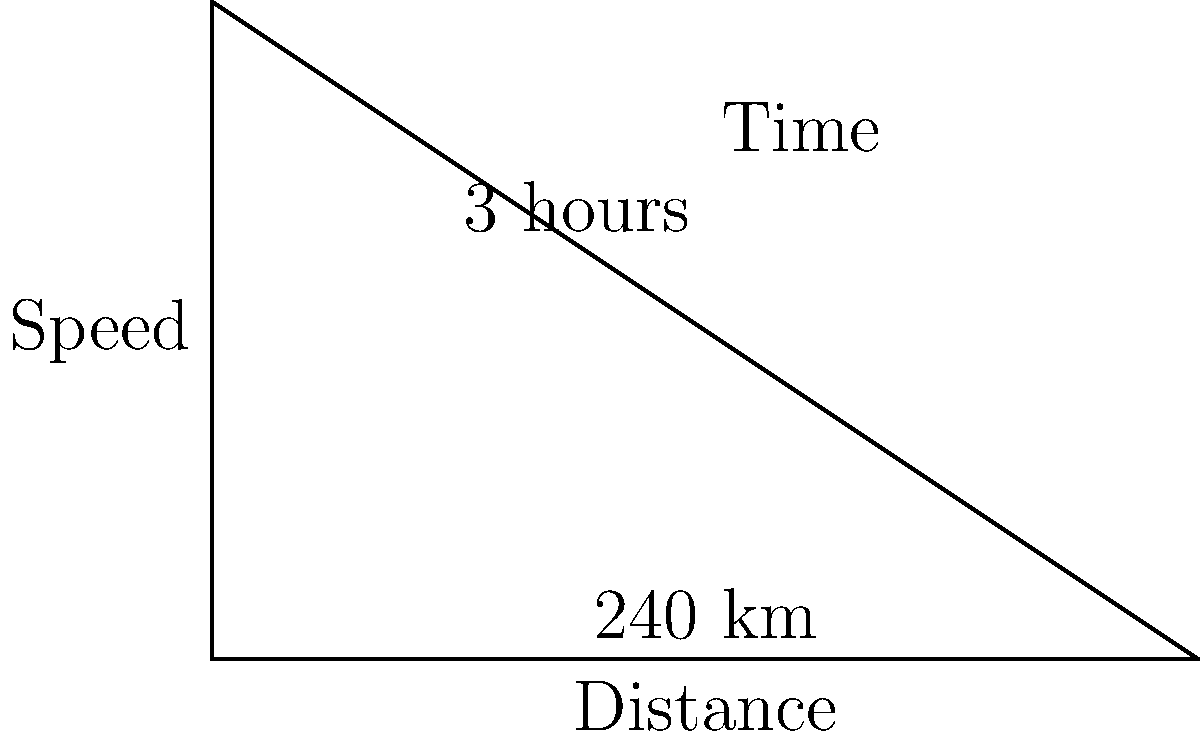A train enthusiast in Georgia is planning a trip from Atlanta to Savannah. The distance between the two cities is 240 km, and the journey takes 3 hours. Using the speed-distance-time triangle diagram provided, calculate the average speed of the train during this trip. To solve this problem, we'll use the speed-distance-time relationship represented by the triangle diagram. Here's a step-by-step approach:

1. Identify the given information:
   - Distance (d) = 240 km
   - Time (t) = 3 hours

2. Recall the formula for average speed:
   $$ \text{Speed} = \frac{\text{Distance}}{\text{Time}} $$

3. Substitute the known values into the formula:
   $$ \text{Speed} = \frac{240 \text{ km}}{3 \text{ hours}} $$

4. Perform the division:
   $$ \text{Speed} = 80 \text{ km/h} $$

5. Check the units:
   The result is in kilometers per hour (km/h), which is a correct unit for speed.

Therefore, the average speed of the train during the trip from Atlanta to Savannah is 80 km/h.
Answer: 80 km/h 